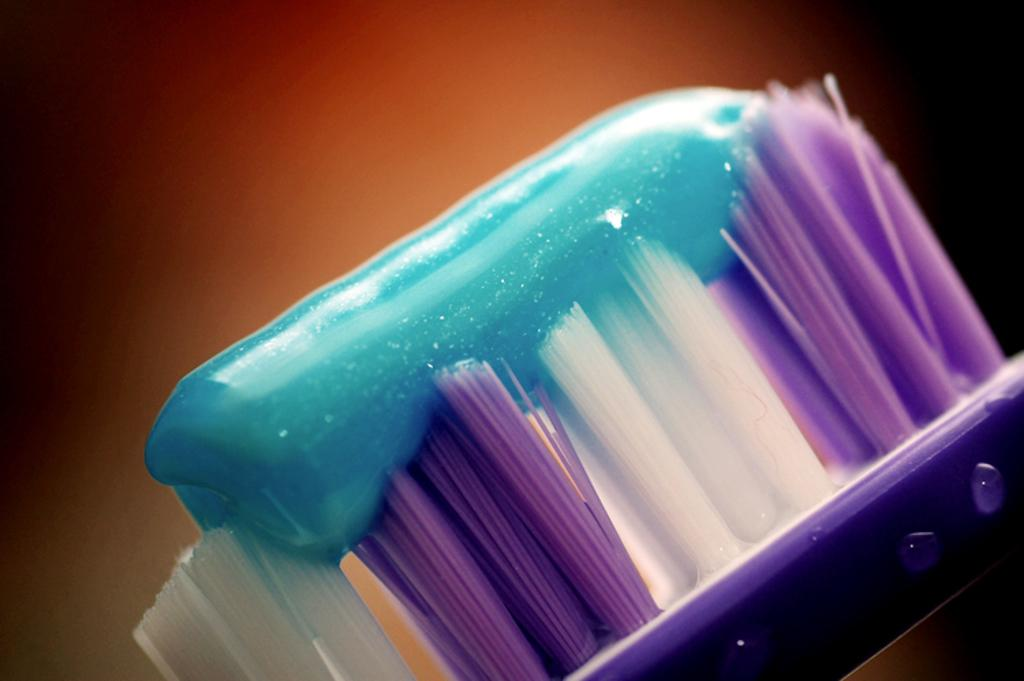What color is the paste on the brush in the image? The paste on the brush is blue. What colors are visible on the brush itself? The brush has white and purple colors. What color is the background of the image? The background of the image is brown. Does the sister in the image have a signed agreement with the lift operator? There is no sister or lift operator present in the image, so it is not possible to determine if they have a signed agreement. 